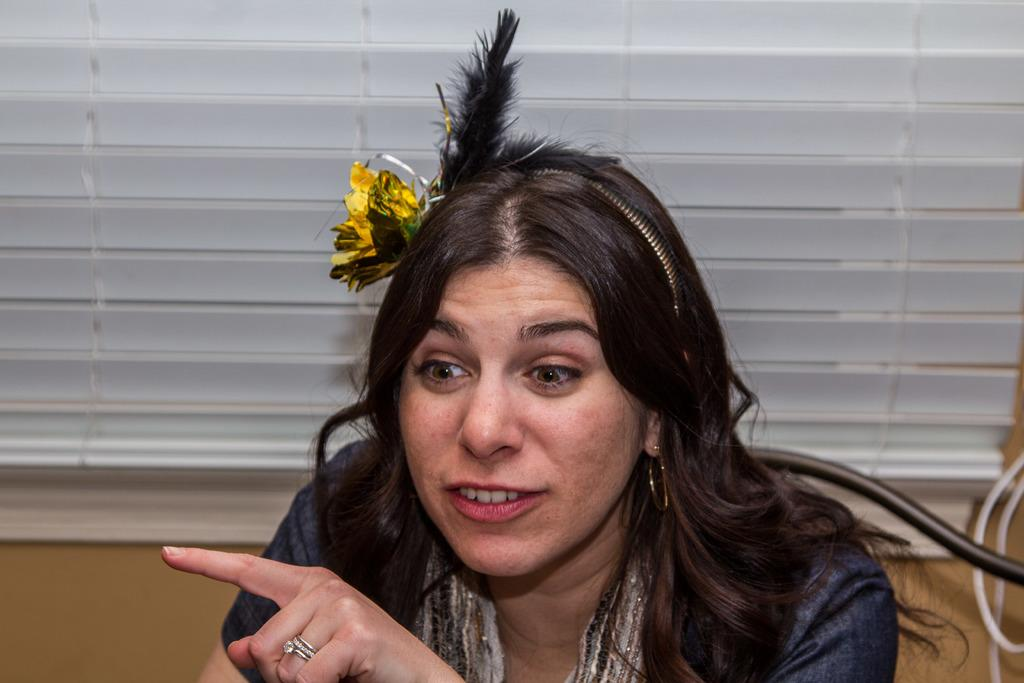Who is present in the image? There is a woman in the image. What can be seen in the background of the image? There is a window blind, a wall, and objects in the background of the image. What type of soup is being served in the image? There is no soup present in the image. Are there any dinosaurs visible in the image? There are no dinosaurs present in the image. 